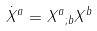Convert formula to latex. <formula><loc_0><loc_0><loc_500><loc_500>\dot { X } ^ { a } = { X ^ { a } } _ { ; b } X ^ { b }</formula> 